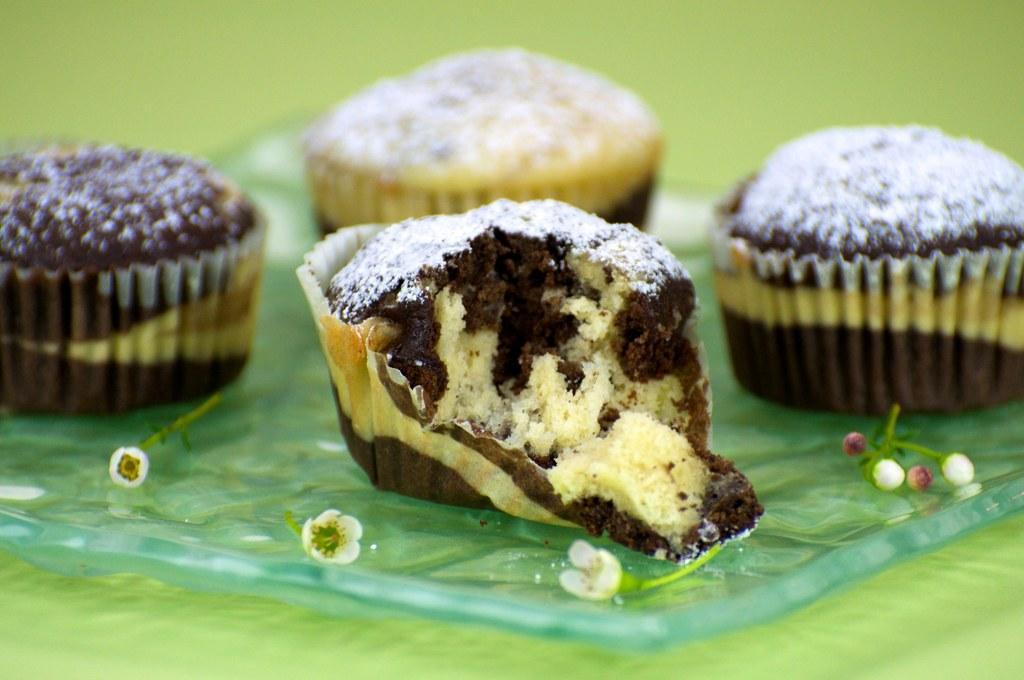How would you summarize this image in a sentence or two? In this image, I can see the tiny flowers and four cupcakes. Among them one cupcake is half eaten. The background is green in color. 